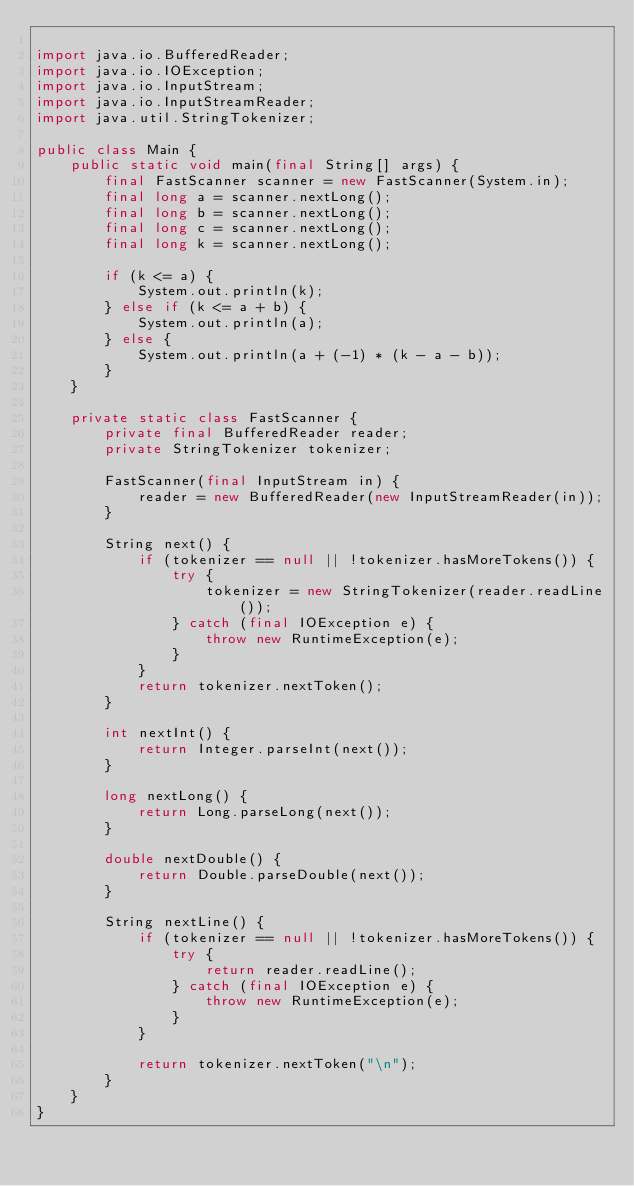<code> <loc_0><loc_0><loc_500><loc_500><_Java_>
import java.io.BufferedReader;
import java.io.IOException;
import java.io.InputStream;
import java.io.InputStreamReader;
import java.util.StringTokenizer;

public class Main {
    public static void main(final String[] args) {
        final FastScanner scanner = new FastScanner(System.in);
        final long a = scanner.nextLong();
        final long b = scanner.nextLong();
        final long c = scanner.nextLong();
        final long k = scanner.nextLong();

        if (k <= a) {
            System.out.println(k);
        } else if (k <= a + b) {
            System.out.println(a);
        } else {
            System.out.println(a + (-1) * (k - a - b));
        }
    }

    private static class FastScanner {
        private final BufferedReader reader;
        private StringTokenizer tokenizer;

        FastScanner(final InputStream in) {
            reader = new BufferedReader(new InputStreamReader(in));
        }

        String next() {
            if (tokenizer == null || !tokenizer.hasMoreTokens()) {
                try {
                    tokenizer = new StringTokenizer(reader.readLine());
                } catch (final IOException e) {
                    throw new RuntimeException(e);
                }
            }
            return tokenizer.nextToken();
        }

        int nextInt() {
            return Integer.parseInt(next());
        }

        long nextLong() {
            return Long.parseLong(next());
        }

        double nextDouble() {
            return Double.parseDouble(next());
        }

        String nextLine() {
            if (tokenizer == null || !tokenizer.hasMoreTokens()) {
                try {
                    return reader.readLine();
                } catch (final IOException e) {
                    throw new RuntimeException(e);
                }
            }

            return tokenizer.nextToken("\n");
        }
    }
}
</code> 